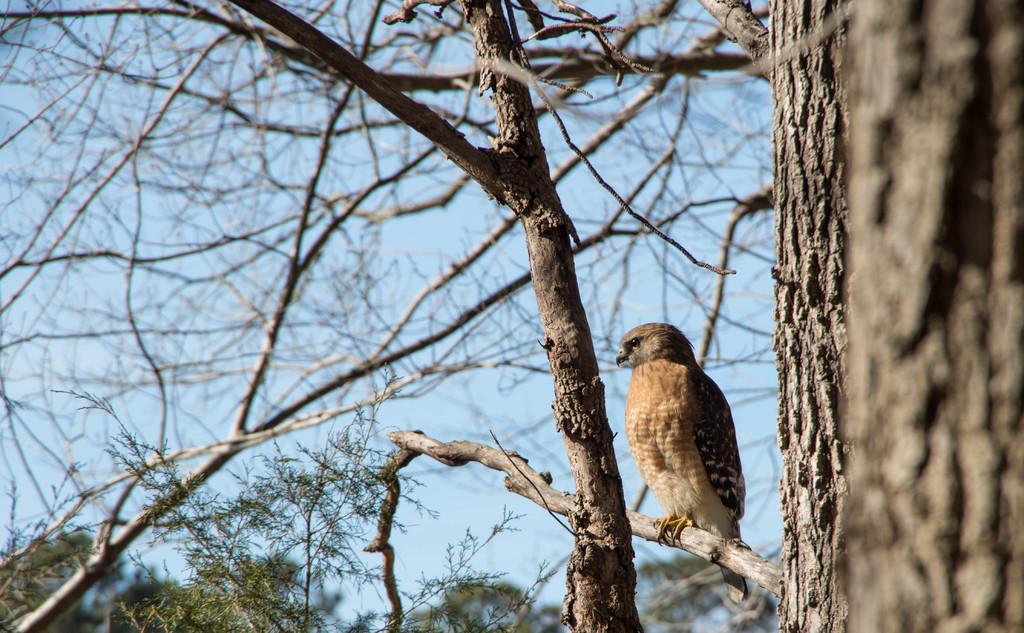Please provide a concise description of this image. In this picture I can see a bird is sitting on the tree. In the background I can see trees and the sky. 